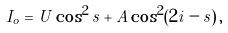<formula> <loc_0><loc_0><loc_500><loc_500>\, I _ { o } = U \cos ^ { 2 } s + A \cos ^ { 2 } ( 2 i - s ) \, ,</formula> 